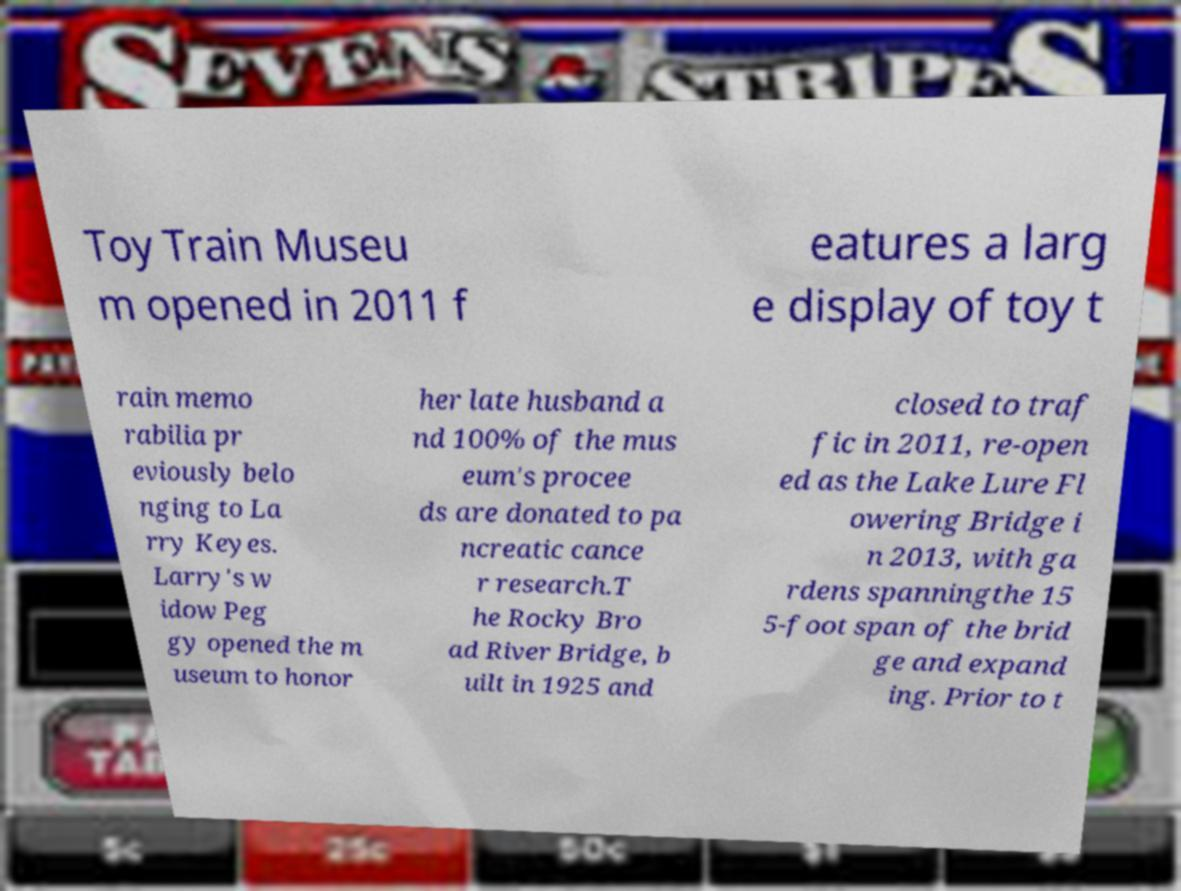There's text embedded in this image that I need extracted. Can you transcribe it verbatim? Toy Train Museu m opened in 2011 f eatures a larg e display of toy t rain memo rabilia pr eviously belo nging to La rry Keyes. Larry's w idow Peg gy opened the m useum to honor her late husband a nd 100% of the mus eum's procee ds are donated to pa ncreatic cance r research.T he Rocky Bro ad River Bridge, b uilt in 1925 and closed to traf fic in 2011, re-open ed as the Lake Lure Fl owering Bridge i n 2013, with ga rdens spanningthe 15 5-foot span of the brid ge and expand ing. Prior to t 